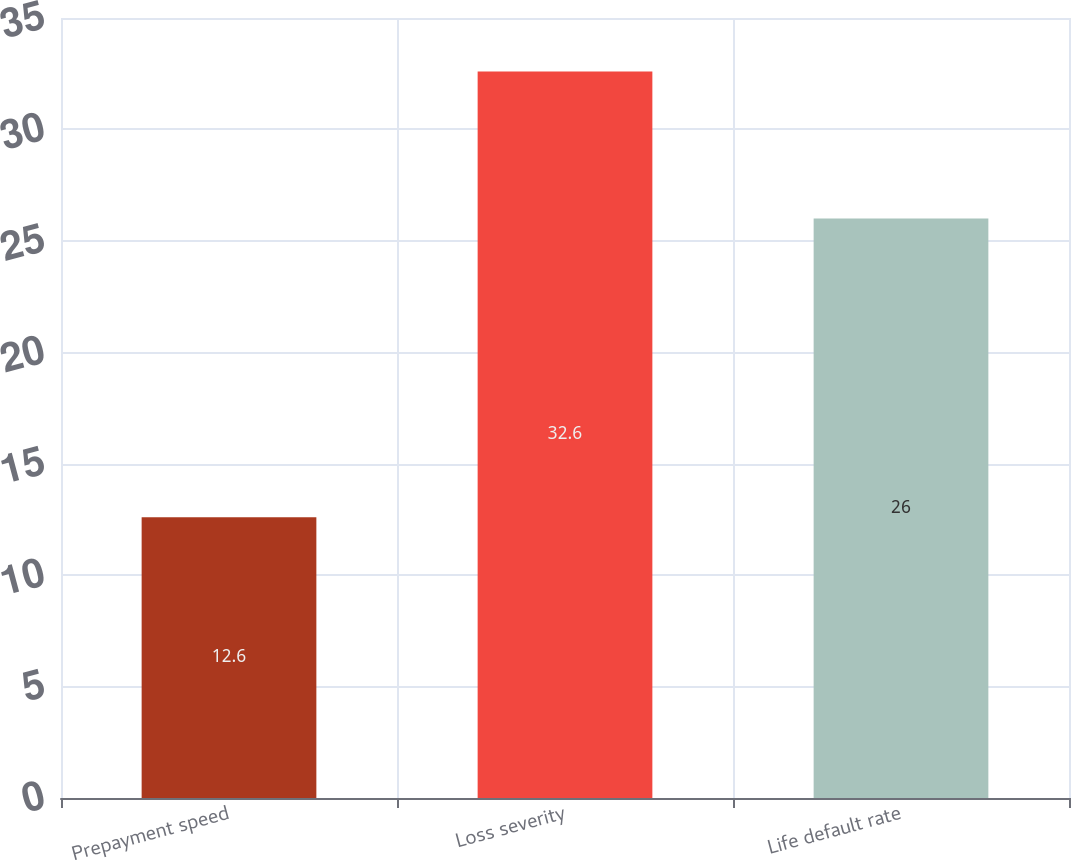Convert chart. <chart><loc_0><loc_0><loc_500><loc_500><bar_chart><fcel>Prepayment speed<fcel>Loss severity<fcel>Life default rate<nl><fcel>12.6<fcel>32.6<fcel>26<nl></chart> 